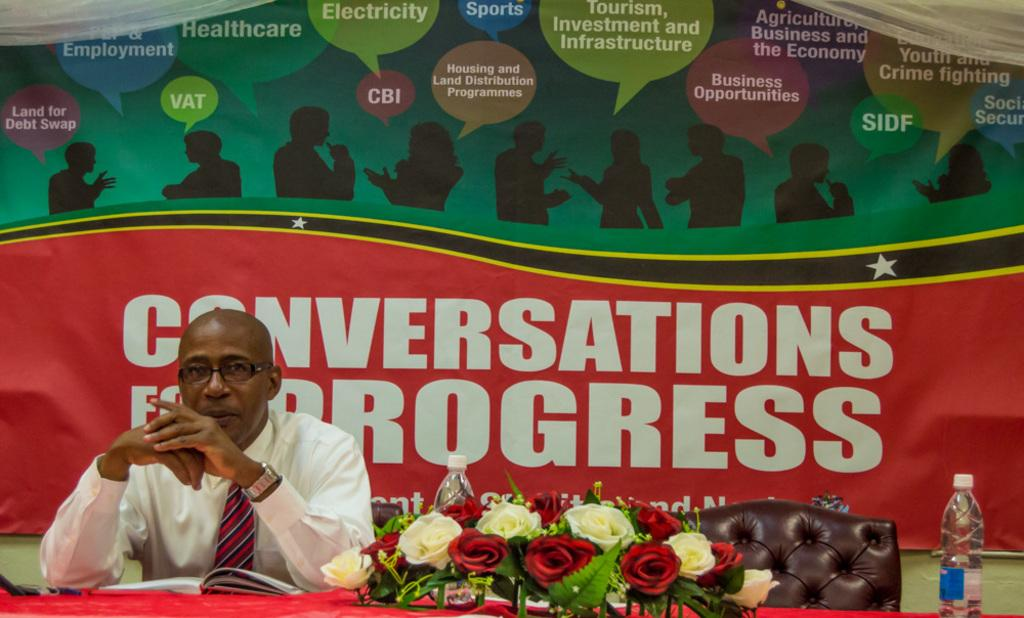What is the appearance of the man in the image? The man in the image is bald-headed. What is the man wearing in the image? The man is wearing a white shirt. Where is the man located in the image? The man is sitting in front of a table. What items can be seen on the table in the image? There are books, flowers, and water bottles on the table. What is hanging on the wall behind the man in the image? There is a banner on the wall behind the man. What type of frame is surrounding the man in the image? There is no frame surrounding the man in the image. How does the man feel about his recent loss in the image? The image does not provide any information about the man's feelings or any recent losses. 